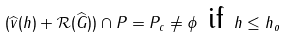<formula> <loc_0><loc_0><loc_500><loc_500>( \widehat { v } ( h ) + \mathcal { R } ( \widehat { G } ) ) \cap P = P _ { c } \neq \phi \text { if } h \leq h _ { o }</formula> 